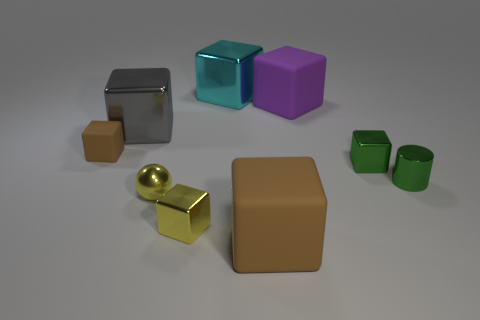Subtract all purple spheres. How many brown cubes are left? 2 Subtract all green shiny blocks. How many blocks are left? 6 Subtract all cyan blocks. How many blocks are left? 6 Subtract all blocks. How many objects are left? 2 Subtract all brown blocks. Subtract all brown cylinders. How many blocks are left? 5 Subtract all small cylinders. Subtract all cylinders. How many objects are left? 7 Add 5 large cyan cubes. How many large cyan cubes are left? 6 Add 4 brown things. How many brown things exist? 6 Subtract 0 blue blocks. How many objects are left? 9 